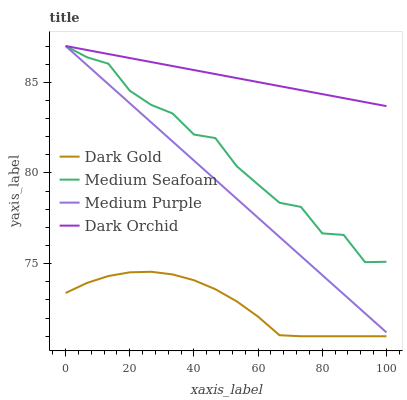Does Dark Gold have the minimum area under the curve?
Answer yes or no. Yes. Does Dark Orchid have the maximum area under the curve?
Answer yes or no. Yes. Does Medium Seafoam have the minimum area under the curve?
Answer yes or no. No. Does Medium Seafoam have the maximum area under the curve?
Answer yes or no. No. Is Dark Orchid the smoothest?
Answer yes or no. Yes. Is Medium Seafoam the roughest?
Answer yes or no. Yes. Is Medium Seafoam the smoothest?
Answer yes or no. No. Is Dark Orchid the roughest?
Answer yes or no. No. Does Dark Gold have the lowest value?
Answer yes or no. Yes. Does Medium Seafoam have the lowest value?
Answer yes or no. No. Does Dark Orchid have the highest value?
Answer yes or no. Yes. Does Dark Gold have the highest value?
Answer yes or no. No. Is Dark Gold less than Medium Seafoam?
Answer yes or no. Yes. Is Medium Purple greater than Dark Gold?
Answer yes or no. Yes. Does Medium Purple intersect Medium Seafoam?
Answer yes or no. Yes. Is Medium Purple less than Medium Seafoam?
Answer yes or no. No. Is Medium Purple greater than Medium Seafoam?
Answer yes or no. No. Does Dark Gold intersect Medium Seafoam?
Answer yes or no. No. 